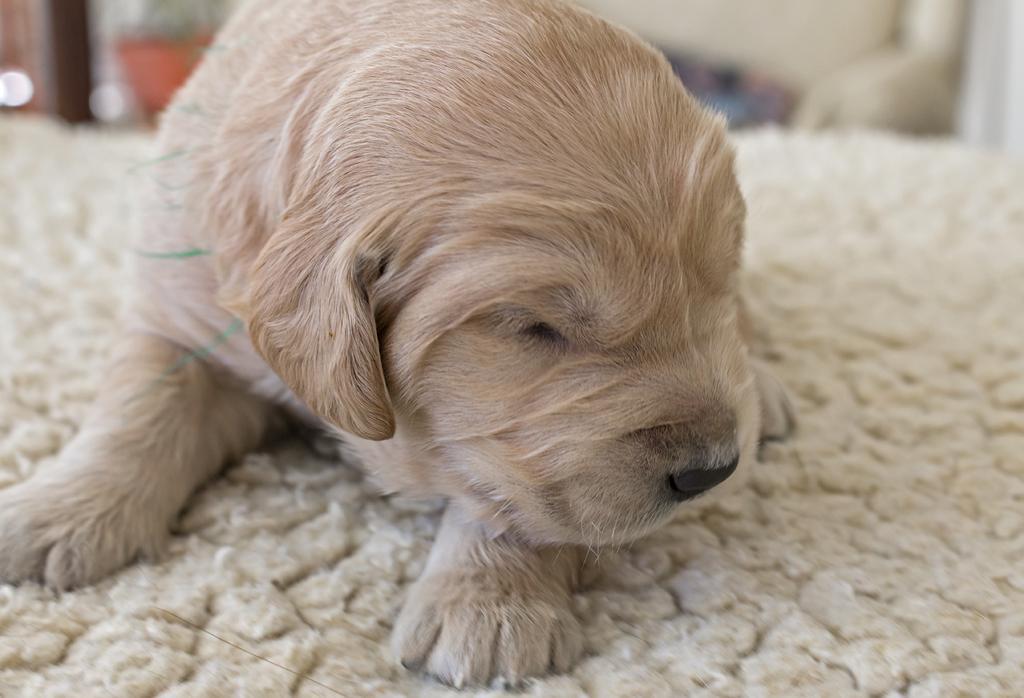In one or two sentences, can you explain what this image depicts? In this image we can see a dog sleeping on the surface. 